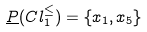Convert formula to latex. <formula><loc_0><loc_0><loc_500><loc_500>\underline { P } ( C l _ { 1 } ^ { \leq } ) = \{ x _ { 1 } , x _ { 5 } \}</formula> 